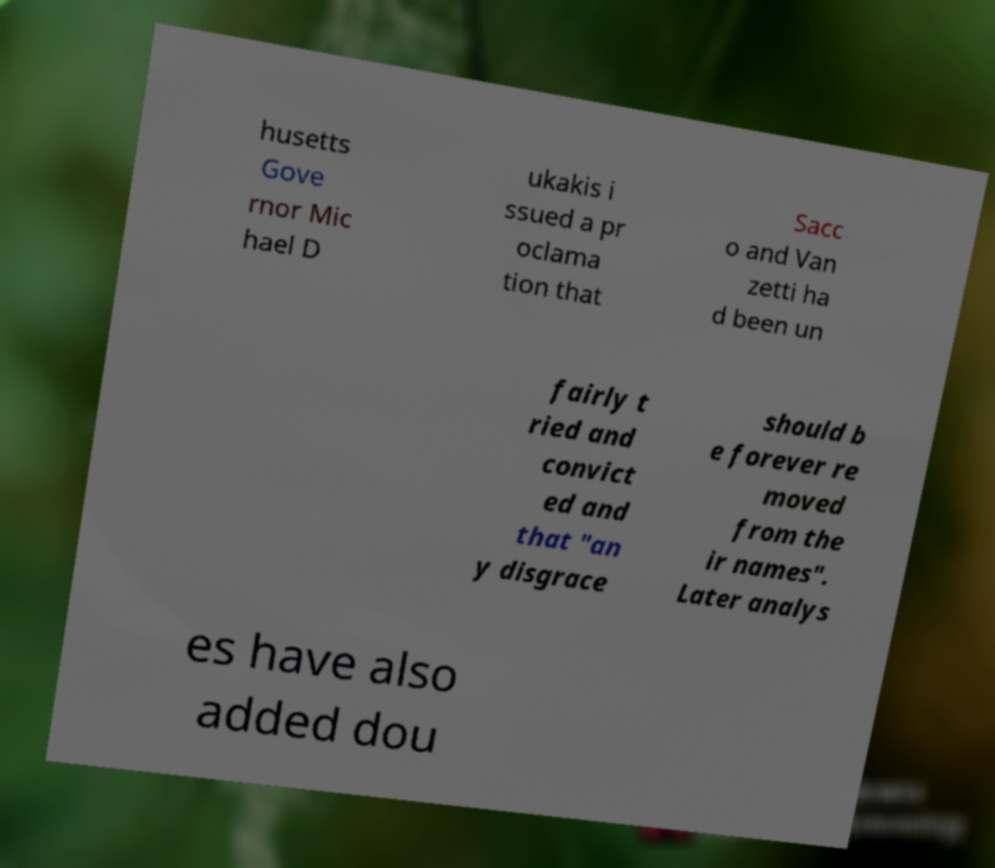Can you accurately transcribe the text from the provided image for me? husetts Gove rnor Mic hael D ukakis i ssued a pr oclama tion that Sacc o and Van zetti ha d been un fairly t ried and convict ed and that "an y disgrace should b e forever re moved from the ir names". Later analys es have also added dou 